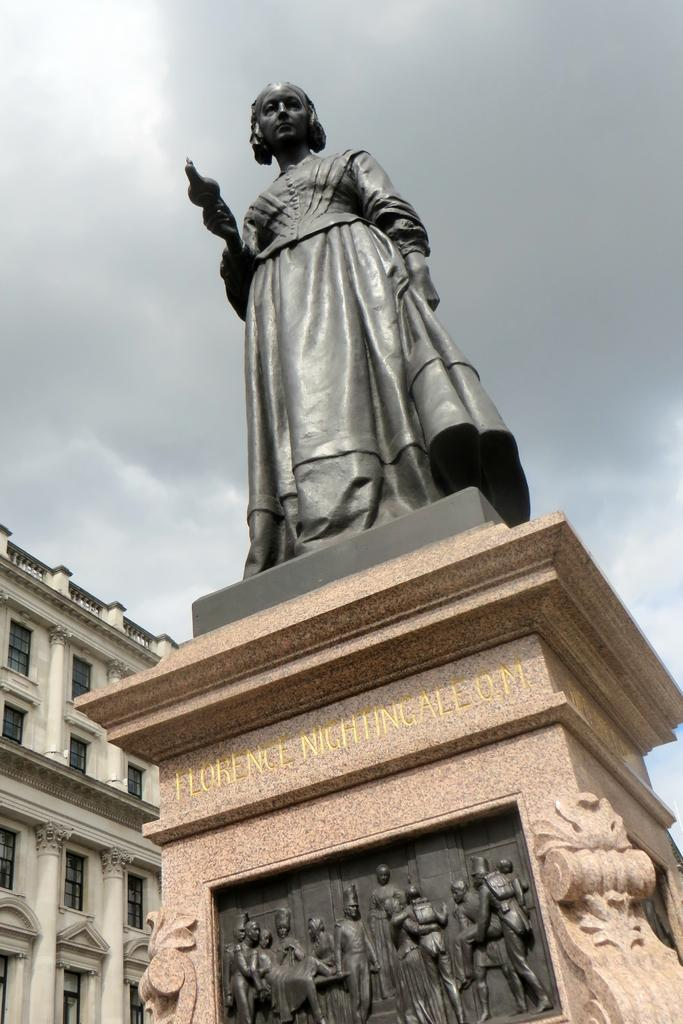What is the main subject in the center of the image? There is a statue in the center of the image. What else can be seen in the image besides the statue? There are sculptures in the image. What is a notable feature of the statue and sculptures? The statue and sculptures have text on them. What can be seen in the background of the image? There is a building and the sky visible in the background of the image. What type of suit is the statue wearing in the image? The statue does not have a suit, as it is a sculpture made of a material such as stone or metal. 